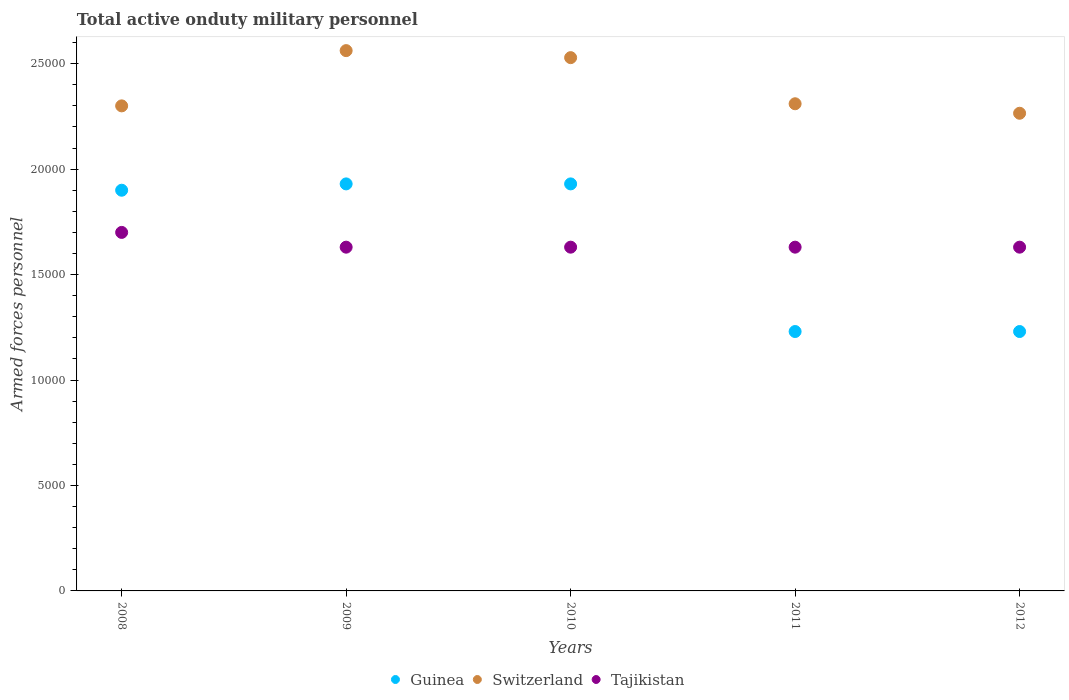What is the number of armed forces personnel in Guinea in 2008?
Provide a succinct answer. 1.90e+04. Across all years, what is the maximum number of armed forces personnel in Tajikistan?
Your answer should be very brief. 1.70e+04. Across all years, what is the minimum number of armed forces personnel in Switzerland?
Your response must be concise. 2.26e+04. What is the total number of armed forces personnel in Switzerland in the graph?
Your answer should be compact. 1.20e+05. What is the difference between the number of armed forces personnel in Switzerland in 2009 and that in 2010?
Give a very brief answer. 333. What is the difference between the number of armed forces personnel in Tajikistan in 2012 and the number of armed forces personnel in Guinea in 2009?
Ensure brevity in your answer.  -3000. What is the average number of armed forces personnel in Guinea per year?
Offer a very short reply. 1.64e+04. In the year 2011, what is the difference between the number of armed forces personnel in Switzerland and number of armed forces personnel in Guinea?
Keep it short and to the point. 1.08e+04. What is the ratio of the number of armed forces personnel in Switzerland in 2008 to that in 2010?
Your answer should be very brief. 0.91. Is the number of armed forces personnel in Tajikistan in 2009 less than that in 2012?
Keep it short and to the point. No. What is the difference between the highest and the second highest number of armed forces personnel in Guinea?
Your answer should be compact. 0. What is the difference between the highest and the lowest number of armed forces personnel in Switzerland?
Offer a terse response. 2970. Is the number of armed forces personnel in Tajikistan strictly less than the number of armed forces personnel in Switzerland over the years?
Keep it short and to the point. Yes. How many dotlines are there?
Offer a very short reply. 3. How many years are there in the graph?
Keep it short and to the point. 5. What is the difference between two consecutive major ticks on the Y-axis?
Ensure brevity in your answer.  5000. Are the values on the major ticks of Y-axis written in scientific E-notation?
Provide a short and direct response. No. Does the graph contain any zero values?
Offer a very short reply. No. Does the graph contain grids?
Give a very brief answer. No. What is the title of the graph?
Provide a succinct answer. Total active onduty military personnel. Does "Greece" appear as one of the legend labels in the graph?
Provide a short and direct response. No. What is the label or title of the Y-axis?
Offer a terse response. Armed forces personnel. What is the Armed forces personnel in Guinea in 2008?
Provide a succinct answer. 1.90e+04. What is the Armed forces personnel in Switzerland in 2008?
Your answer should be compact. 2.30e+04. What is the Armed forces personnel of Tajikistan in 2008?
Make the answer very short. 1.70e+04. What is the Armed forces personnel in Guinea in 2009?
Make the answer very short. 1.93e+04. What is the Armed forces personnel of Switzerland in 2009?
Give a very brief answer. 2.56e+04. What is the Armed forces personnel of Tajikistan in 2009?
Keep it short and to the point. 1.63e+04. What is the Armed forces personnel of Guinea in 2010?
Your answer should be compact. 1.93e+04. What is the Armed forces personnel in Switzerland in 2010?
Your answer should be very brief. 2.53e+04. What is the Armed forces personnel in Tajikistan in 2010?
Your response must be concise. 1.63e+04. What is the Armed forces personnel of Guinea in 2011?
Your answer should be compact. 1.23e+04. What is the Armed forces personnel in Switzerland in 2011?
Provide a succinct answer. 2.31e+04. What is the Armed forces personnel of Tajikistan in 2011?
Make the answer very short. 1.63e+04. What is the Armed forces personnel of Guinea in 2012?
Give a very brief answer. 1.23e+04. What is the Armed forces personnel in Switzerland in 2012?
Give a very brief answer. 2.26e+04. What is the Armed forces personnel of Tajikistan in 2012?
Ensure brevity in your answer.  1.63e+04. Across all years, what is the maximum Armed forces personnel in Guinea?
Your response must be concise. 1.93e+04. Across all years, what is the maximum Armed forces personnel of Switzerland?
Your answer should be compact. 2.56e+04. Across all years, what is the maximum Armed forces personnel in Tajikistan?
Provide a short and direct response. 1.70e+04. Across all years, what is the minimum Armed forces personnel of Guinea?
Ensure brevity in your answer.  1.23e+04. Across all years, what is the minimum Armed forces personnel of Switzerland?
Provide a succinct answer. 2.26e+04. Across all years, what is the minimum Armed forces personnel in Tajikistan?
Your answer should be compact. 1.63e+04. What is the total Armed forces personnel of Guinea in the graph?
Provide a succinct answer. 8.22e+04. What is the total Armed forces personnel in Switzerland in the graph?
Your answer should be very brief. 1.20e+05. What is the total Armed forces personnel of Tajikistan in the graph?
Provide a short and direct response. 8.22e+04. What is the difference between the Armed forces personnel in Guinea in 2008 and that in 2009?
Offer a terse response. -300. What is the difference between the Armed forces personnel in Switzerland in 2008 and that in 2009?
Provide a short and direct response. -2620. What is the difference between the Armed forces personnel in Tajikistan in 2008 and that in 2009?
Provide a succinct answer. 700. What is the difference between the Armed forces personnel in Guinea in 2008 and that in 2010?
Provide a succinct answer. -300. What is the difference between the Armed forces personnel in Switzerland in 2008 and that in 2010?
Your response must be concise. -2287. What is the difference between the Armed forces personnel of Tajikistan in 2008 and that in 2010?
Make the answer very short. 700. What is the difference between the Armed forces personnel in Guinea in 2008 and that in 2011?
Provide a short and direct response. 6700. What is the difference between the Armed forces personnel of Switzerland in 2008 and that in 2011?
Your answer should be very brief. -100. What is the difference between the Armed forces personnel of Tajikistan in 2008 and that in 2011?
Ensure brevity in your answer.  700. What is the difference between the Armed forces personnel in Guinea in 2008 and that in 2012?
Your answer should be compact. 6700. What is the difference between the Armed forces personnel of Switzerland in 2008 and that in 2012?
Keep it short and to the point. 350. What is the difference between the Armed forces personnel of Tajikistan in 2008 and that in 2012?
Your answer should be compact. 700. What is the difference between the Armed forces personnel in Switzerland in 2009 and that in 2010?
Your answer should be compact. 333. What is the difference between the Armed forces personnel in Tajikistan in 2009 and that in 2010?
Ensure brevity in your answer.  0. What is the difference between the Armed forces personnel in Guinea in 2009 and that in 2011?
Make the answer very short. 7000. What is the difference between the Armed forces personnel in Switzerland in 2009 and that in 2011?
Give a very brief answer. 2520. What is the difference between the Armed forces personnel in Guinea in 2009 and that in 2012?
Make the answer very short. 7000. What is the difference between the Armed forces personnel of Switzerland in 2009 and that in 2012?
Your answer should be compact. 2970. What is the difference between the Armed forces personnel in Tajikistan in 2009 and that in 2012?
Provide a succinct answer. 0. What is the difference between the Armed forces personnel of Guinea in 2010 and that in 2011?
Your answer should be compact. 7000. What is the difference between the Armed forces personnel of Switzerland in 2010 and that in 2011?
Your answer should be compact. 2187. What is the difference between the Armed forces personnel in Tajikistan in 2010 and that in 2011?
Provide a short and direct response. 0. What is the difference between the Armed forces personnel in Guinea in 2010 and that in 2012?
Offer a very short reply. 7000. What is the difference between the Armed forces personnel of Switzerland in 2010 and that in 2012?
Make the answer very short. 2637. What is the difference between the Armed forces personnel in Switzerland in 2011 and that in 2012?
Your answer should be very brief. 450. What is the difference between the Armed forces personnel of Guinea in 2008 and the Armed forces personnel of Switzerland in 2009?
Offer a very short reply. -6620. What is the difference between the Armed forces personnel in Guinea in 2008 and the Armed forces personnel in Tajikistan in 2009?
Keep it short and to the point. 2700. What is the difference between the Armed forces personnel of Switzerland in 2008 and the Armed forces personnel of Tajikistan in 2009?
Provide a short and direct response. 6700. What is the difference between the Armed forces personnel of Guinea in 2008 and the Armed forces personnel of Switzerland in 2010?
Offer a very short reply. -6287. What is the difference between the Armed forces personnel in Guinea in 2008 and the Armed forces personnel in Tajikistan in 2010?
Your answer should be very brief. 2700. What is the difference between the Armed forces personnel of Switzerland in 2008 and the Armed forces personnel of Tajikistan in 2010?
Provide a succinct answer. 6700. What is the difference between the Armed forces personnel in Guinea in 2008 and the Armed forces personnel in Switzerland in 2011?
Ensure brevity in your answer.  -4100. What is the difference between the Armed forces personnel in Guinea in 2008 and the Armed forces personnel in Tajikistan in 2011?
Provide a succinct answer. 2700. What is the difference between the Armed forces personnel in Switzerland in 2008 and the Armed forces personnel in Tajikistan in 2011?
Offer a very short reply. 6700. What is the difference between the Armed forces personnel in Guinea in 2008 and the Armed forces personnel in Switzerland in 2012?
Give a very brief answer. -3650. What is the difference between the Armed forces personnel of Guinea in 2008 and the Armed forces personnel of Tajikistan in 2012?
Your answer should be very brief. 2700. What is the difference between the Armed forces personnel of Switzerland in 2008 and the Armed forces personnel of Tajikistan in 2012?
Keep it short and to the point. 6700. What is the difference between the Armed forces personnel of Guinea in 2009 and the Armed forces personnel of Switzerland in 2010?
Offer a very short reply. -5987. What is the difference between the Armed forces personnel of Guinea in 2009 and the Armed forces personnel of Tajikistan in 2010?
Provide a short and direct response. 3000. What is the difference between the Armed forces personnel in Switzerland in 2009 and the Armed forces personnel in Tajikistan in 2010?
Make the answer very short. 9320. What is the difference between the Armed forces personnel of Guinea in 2009 and the Armed forces personnel of Switzerland in 2011?
Offer a very short reply. -3800. What is the difference between the Armed forces personnel in Guinea in 2009 and the Armed forces personnel in Tajikistan in 2011?
Your answer should be very brief. 3000. What is the difference between the Armed forces personnel in Switzerland in 2009 and the Armed forces personnel in Tajikistan in 2011?
Give a very brief answer. 9320. What is the difference between the Armed forces personnel in Guinea in 2009 and the Armed forces personnel in Switzerland in 2012?
Offer a very short reply. -3350. What is the difference between the Armed forces personnel of Guinea in 2009 and the Armed forces personnel of Tajikistan in 2012?
Provide a succinct answer. 3000. What is the difference between the Armed forces personnel in Switzerland in 2009 and the Armed forces personnel in Tajikistan in 2012?
Your response must be concise. 9320. What is the difference between the Armed forces personnel of Guinea in 2010 and the Armed forces personnel of Switzerland in 2011?
Provide a succinct answer. -3800. What is the difference between the Armed forces personnel of Guinea in 2010 and the Armed forces personnel of Tajikistan in 2011?
Provide a short and direct response. 3000. What is the difference between the Armed forces personnel in Switzerland in 2010 and the Armed forces personnel in Tajikistan in 2011?
Provide a short and direct response. 8987. What is the difference between the Armed forces personnel in Guinea in 2010 and the Armed forces personnel in Switzerland in 2012?
Your response must be concise. -3350. What is the difference between the Armed forces personnel of Guinea in 2010 and the Armed forces personnel of Tajikistan in 2012?
Your response must be concise. 3000. What is the difference between the Armed forces personnel in Switzerland in 2010 and the Armed forces personnel in Tajikistan in 2012?
Make the answer very short. 8987. What is the difference between the Armed forces personnel of Guinea in 2011 and the Armed forces personnel of Switzerland in 2012?
Provide a succinct answer. -1.04e+04. What is the difference between the Armed forces personnel of Guinea in 2011 and the Armed forces personnel of Tajikistan in 2012?
Offer a terse response. -4000. What is the difference between the Armed forces personnel of Switzerland in 2011 and the Armed forces personnel of Tajikistan in 2012?
Provide a short and direct response. 6800. What is the average Armed forces personnel in Guinea per year?
Ensure brevity in your answer.  1.64e+04. What is the average Armed forces personnel in Switzerland per year?
Provide a short and direct response. 2.39e+04. What is the average Armed forces personnel of Tajikistan per year?
Provide a short and direct response. 1.64e+04. In the year 2008, what is the difference between the Armed forces personnel in Guinea and Armed forces personnel in Switzerland?
Provide a short and direct response. -4000. In the year 2008, what is the difference between the Armed forces personnel in Switzerland and Armed forces personnel in Tajikistan?
Keep it short and to the point. 6000. In the year 2009, what is the difference between the Armed forces personnel in Guinea and Armed forces personnel in Switzerland?
Your answer should be compact. -6320. In the year 2009, what is the difference between the Armed forces personnel of Guinea and Armed forces personnel of Tajikistan?
Your answer should be very brief. 3000. In the year 2009, what is the difference between the Armed forces personnel of Switzerland and Armed forces personnel of Tajikistan?
Your answer should be compact. 9320. In the year 2010, what is the difference between the Armed forces personnel of Guinea and Armed forces personnel of Switzerland?
Your answer should be compact. -5987. In the year 2010, what is the difference between the Armed forces personnel of Guinea and Armed forces personnel of Tajikistan?
Your response must be concise. 3000. In the year 2010, what is the difference between the Armed forces personnel of Switzerland and Armed forces personnel of Tajikistan?
Give a very brief answer. 8987. In the year 2011, what is the difference between the Armed forces personnel of Guinea and Armed forces personnel of Switzerland?
Offer a terse response. -1.08e+04. In the year 2011, what is the difference between the Armed forces personnel in Guinea and Armed forces personnel in Tajikistan?
Make the answer very short. -4000. In the year 2011, what is the difference between the Armed forces personnel of Switzerland and Armed forces personnel of Tajikistan?
Offer a terse response. 6800. In the year 2012, what is the difference between the Armed forces personnel in Guinea and Armed forces personnel in Switzerland?
Give a very brief answer. -1.04e+04. In the year 2012, what is the difference between the Armed forces personnel in Guinea and Armed forces personnel in Tajikistan?
Ensure brevity in your answer.  -4000. In the year 2012, what is the difference between the Armed forces personnel in Switzerland and Armed forces personnel in Tajikistan?
Provide a short and direct response. 6350. What is the ratio of the Armed forces personnel of Guinea in 2008 to that in 2009?
Offer a very short reply. 0.98. What is the ratio of the Armed forces personnel of Switzerland in 2008 to that in 2009?
Ensure brevity in your answer.  0.9. What is the ratio of the Armed forces personnel of Tajikistan in 2008 to that in 2009?
Your response must be concise. 1.04. What is the ratio of the Armed forces personnel of Guinea in 2008 to that in 2010?
Offer a very short reply. 0.98. What is the ratio of the Armed forces personnel in Switzerland in 2008 to that in 2010?
Give a very brief answer. 0.91. What is the ratio of the Armed forces personnel in Tajikistan in 2008 to that in 2010?
Offer a very short reply. 1.04. What is the ratio of the Armed forces personnel in Guinea in 2008 to that in 2011?
Offer a very short reply. 1.54. What is the ratio of the Armed forces personnel of Tajikistan in 2008 to that in 2011?
Ensure brevity in your answer.  1.04. What is the ratio of the Armed forces personnel of Guinea in 2008 to that in 2012?
Give a very brief answer. 1.54. What is the ratio of the Armed forces personnel in Switzerland in 2008 to that in 2012?
Your answer should be compact. 1.02. What is the ratio of the Armed forces personnel of Tajikistan in 2008 to that in 2012?
Keep it short and to the point. 1.04. What is the ratio of the Armed forces personnel in Guinea in 2009 to that in 2010?
Make the answer very short. 1. What is the ratio of the Armed forces personnel of Switzerland in 2009 to that in 2010?
Your answer should be very brief. 1.01. What is the ratio of the Armed forces personnel in Guinea in 2009 to that in 2011?
Provide a succinct answer. 1.57. What is the ratio of the Armed forces personnel in Switzerland in 2009 to that in 2011?
Offer a very short reply. 1.11. What is the ratio of the Armed forces personnel of Tajikistan in 2009 to that in 2011?
Offer a very short reply. 1. What is the ratio of the Armed forces personnel in Guinea in 2009 to that in 2012?
Make the answer very short. 1.57. What is the ratio of the Armed forces personnel of Switzerland in 2009 to that in 2012?
Give a very brief answer. 1.13. What is the ratio of the Armed forces personnel of Tajikistan in 2009 to that in 2012?
Your answer should be very brief. 1. What is the ratio of the Armed forces personnel in Guinea in 2010 to that in 2011?
Your response must be concise. 1.57. What is the ratio of the Armed forces personnel of Switzerland in 2010 to that in 2011?
Your response must be concise. 1.09. What is the ratio of the Armed forces personnel of Guinea in 2010 to that in 2012?
Offer a very short reply. 1.57. What is the ratio of the Armed forces personnel of Switzerland in 2010 to that in 2012?
Your answer should be compact. 1.12. What is the ratio of the Armed forces personnel of Switzerland in 2011 to that in 2012?
Provide a short and direct response. 1.02. What is the difference between the highest and the second highest Armed forces personnel of Guinea?
Your response must be concise. 0. What is the difference between the highest and the second highest Armed forces personnel of Switzerland?
Your answer should be very brief. 333. What is the difference between the highest and the second highest Armed forces personnel in Tajikistan?
Your response must be concise. 700. What is the difference between the highest and the lowest Armed forces personnel in Guinea?
Your answer should be compact. 7000. What is the difference between the highest and the lowest Armed forces personnel of Switzerland?
Offer a very short reply. 2970. What is the difference between the highest and the lowest Armed forces personnel in Tajikistan?
Your answer should be compact. 700. 